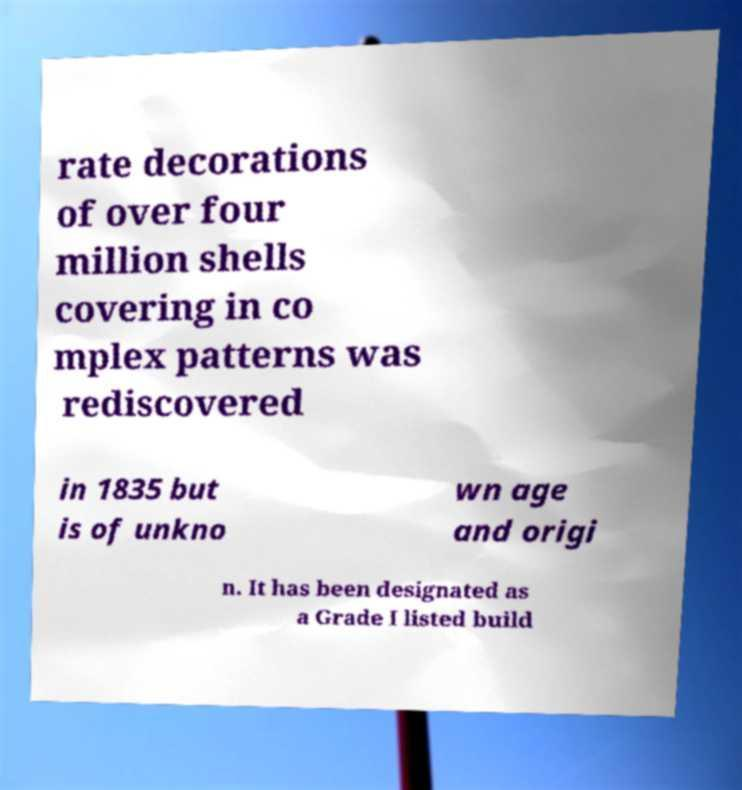What messages or text are displayed in this image? I need them in a readable, typed format. rate decorations of over four million shells covering in co mplex patterns was rediscovered in 1835 but is of unkno wn age and origi n. It has been designated as a Grade I listed build 